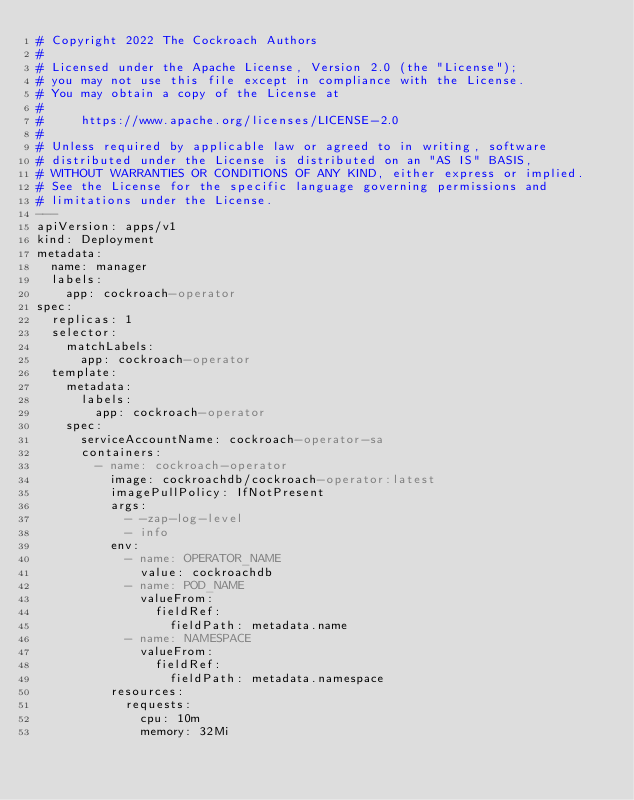<code> <loc_0><loc_0><loc_500><loc_500><_YAML_># Copyright 2022 The Cockroach Authors
#
# Licensed under the Apache License, Version 2.0 (the "License");
# you may not use this file except in compliance with the License.
# You may obtain a copy of the License at
#
#     https://www.apache.org/licenses/LICENSE-2.0
#
# Unless required by applicable law or agreed to in writing, software
# distributed under the License is distributed on an "AS IS" BASIS,
# WITHOUT WARRANTIES OR CONDITIONS OF ANY KIND, either express or implied.
# See the License for the specific language governing permissions and
# limitations under the License.
---
apiVersion: apps/v1
kind: Deployment
metadata:
  name: manager
  labels:
    app: cockroach-operator
spec:
  replicas: 1
  selector:
    matchLabels:
      app: cockroach-operator
  template:
    metadata:
      labels:
        app: cockroach-operator
    spec:
      serviceAccountName: cockroach-operator-sa
      containers:
        - name: cockroach-operator
          image: cockroachdb/cockroach-operator:latest
          imagePullPolicy: IfNotPresent
          args:
            - -zap-log-level
            - info
          env:
            - name: OPERATOR_NAME
              value: cockroachdb
            - name: POD_NAME
              valueFrom:
                fieldRef:
                  fieldPath: metadata.name
            - name: NAMESPACE
              valueFrom:
                fieldRef:
                  fieldPath: metadata.namespace
          resources:
            requests:
              cpu: 10m
              memory: 32Mi
</code> 